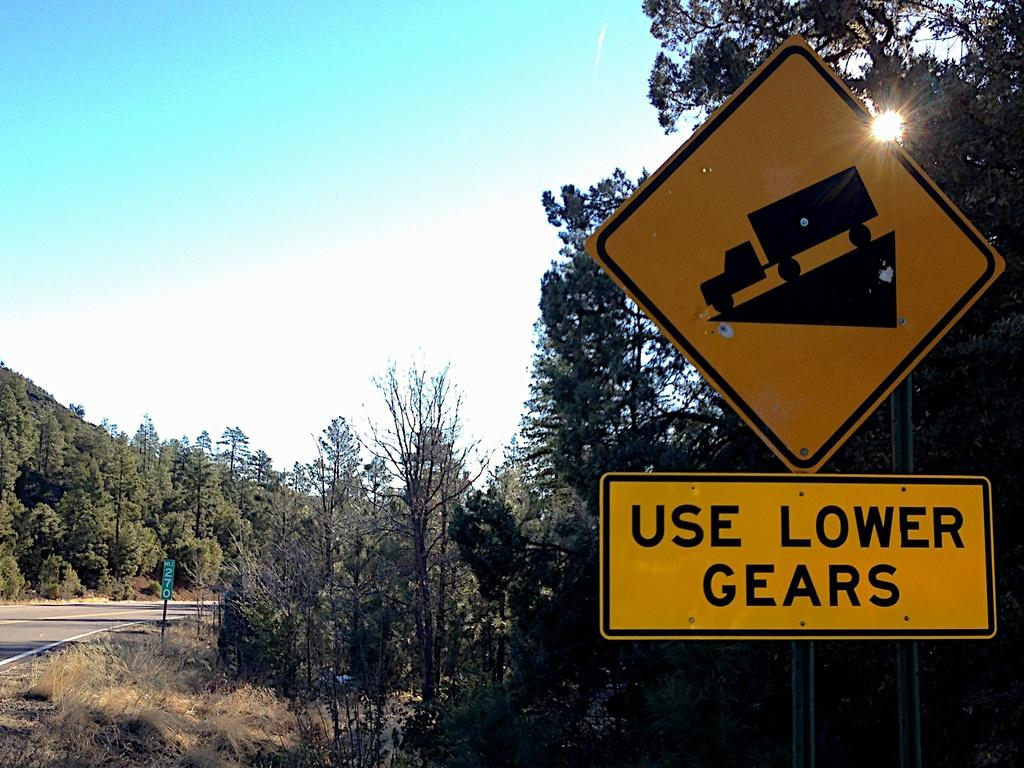Provide a one-sentence caption for the provided image. Big, heavy trucks need to use a lower gear to go down the steep grade. 